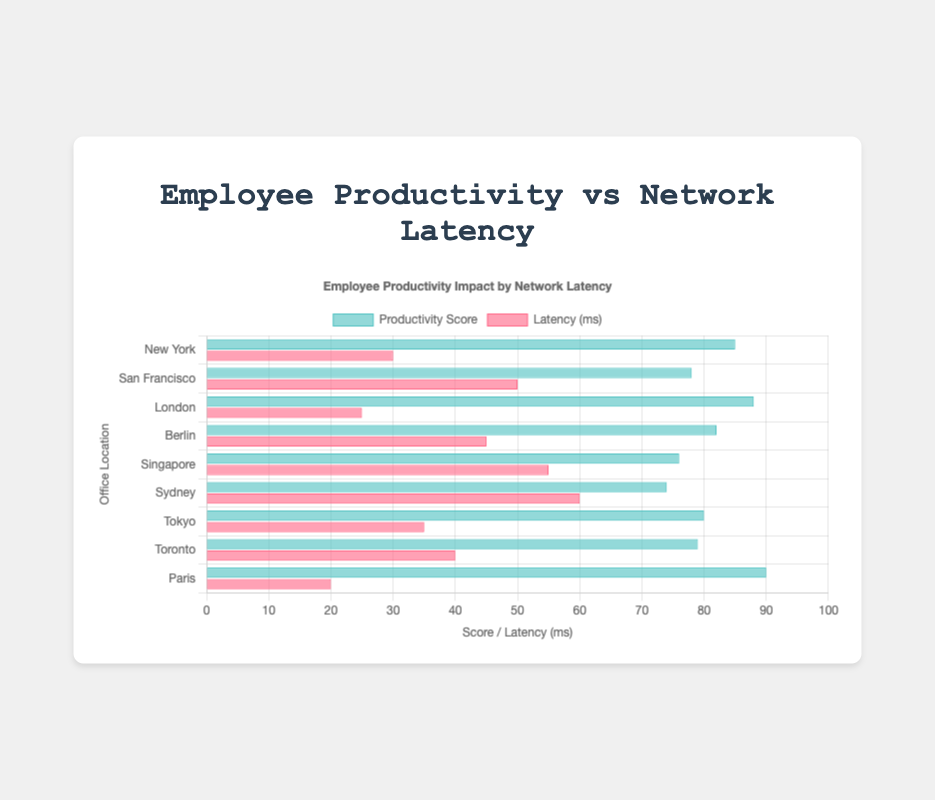Which office location has the highest productivity score? We can find the highest bar on the "Productivity Score" dataset, which is represented in green. The highest bar corresponds to Paris.
Answer: Paris Which office location has the highest network latency? We can find the highest bar on the "Latency (ms)" dataset, which is represented in red. The highest latency is found in Sydney.
Answer: Sydney Compare the productivity score between Paris and Sydney. Which one is higher and by how much? Paris has a productivity score of 90, and Sydney has a score of 74. Subtracting Sydney's score from Paris's score: 90 - 74 = 16.
Answer: Paris, by 16 What is the average network latency across all office locations? Sum all the average latency values and divide by the number of locations: (30 + 50 + 25 + 45 + 55 + 60 + 35 + 40 + 20) / 9 = 40 ms.
Answer: 40 ms Is there a relationship visible between average latency and productivity scores? Looking at the bars, in general it appears that higher latency correlates with lower productivity scores, but there are exceptions like Tokyo and Toronto with average latency and relatively stable productivity scores.
Answer: Yes, generally but not perfectly What is the combined productivity score of the top three office locations in terms of productivity? Identify the top three productivity scores (Paris: 90, London: 88, New York: 85), then add them together: 90 + 88 + 85 = 263.
Answer: 263 What is the range of productivity scores observed in the data? The range is calculated by subtracting the smallest productivity score (Sydney: 74) from the highest productivity score (Paris: 90), resulting in: 90 - 74 = 16.
Answer: 16 What is the median network latency from the data set? Organize the latency values in ascending order: 20, 25, 30, 35, 40, 45, 50, 55, 60. The median value is the fifth value in this ordered list: 40 ms.
Answer: 40 ms How much lower is the productivity score of Sydney compared to Berlin? Sydney has a productivity score of 74 and Berlin has a score of 82. Subtract Sydney's score from Berlin's score: 82 - 74 = 8.
Answer: 8 Which office location has the lowest network latency and what is its productivity score? The lowest network latency is in Paris with 20 ms, and its productivity score is 90.
Answer: Paris, 90 